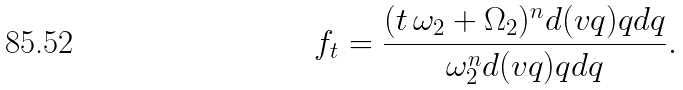Convert formula to latex. <formula><loc_0><loc_0><loc_500><loc_500>f _ { t } = \frac { ( t \, \omega _ { 2 } + \Omega _ { 2 } ) ^ { n } d ( v q ) q d q } { \omega _ { 2 } ^ { n } d ( v q ) q d q } .</formula> 